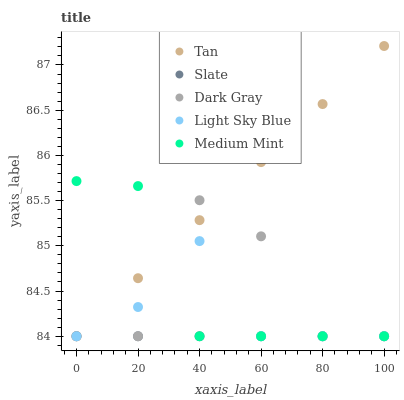Does Slate have the minimum area under the curve?
Answer yes or no. Yes. Does Tan have the maximum area under the curve?
Answer yes or no. Yes. Does Medium Mint have the minimum area under the curve?
Answer yes or no. No. Does Medium Mint have the maximum area under the curve?
Answer yes or no. No. Is Tan the smoothest?
Answer yes or no. Yes. Is Dark Gray the roughest?
Answer yes or no. Yes. Is Medium Mint the smoothest?
Answer yes or no. No. Is Medium Mint the roughest?
Answer yes or no. No. Does Dark Gray have the lowest value?
Answer yes or no. Yes. Does Tan have the highest value?
Answer yes or no. Yes. Does Medium Mint have the highest value?
Answer yes or no. No. Does Tan intersect Slate?
Answer yes or no. Yes. Is Tan less than Slate?
Answer yes or no. No. Is Tan greater than Slate?
Answer yes or no. No. 